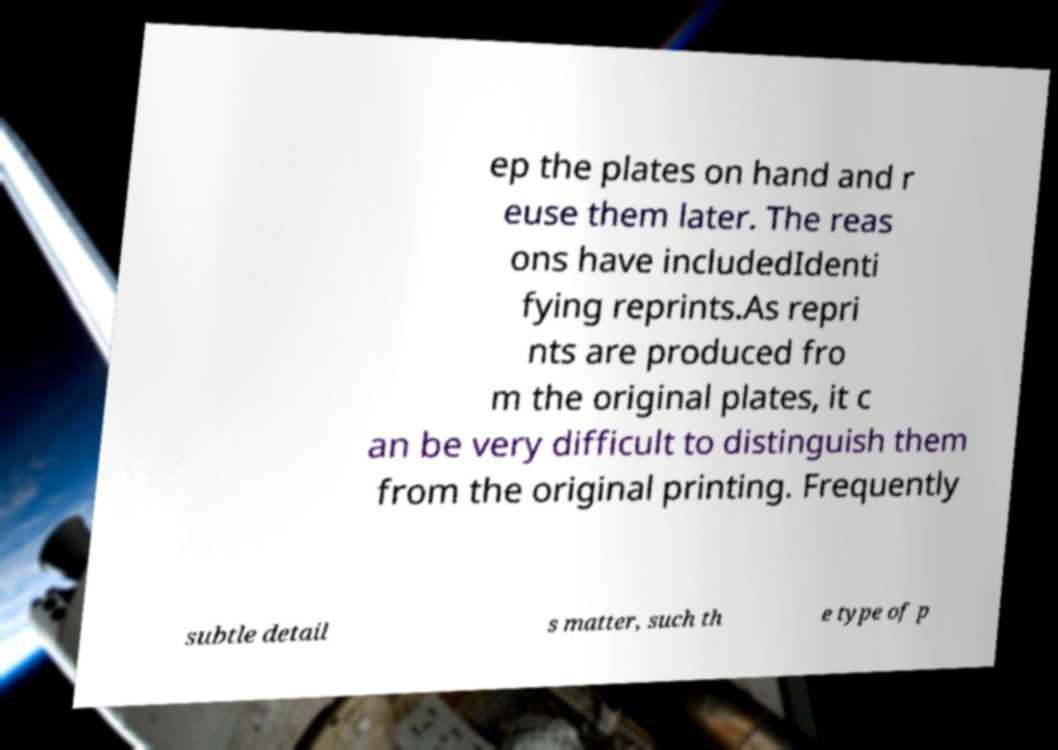There's text embedded in this image that I need extracted. Can you transcribe it verbatim? ep the plates on hand and r euse them later. The reas ons have includedIdenti fying reprints.As repri nts are produced fro m the original plates, it c an be very difficult to distinguish them from the original printing. Frequently subtle detail s matter, such th e type of p 